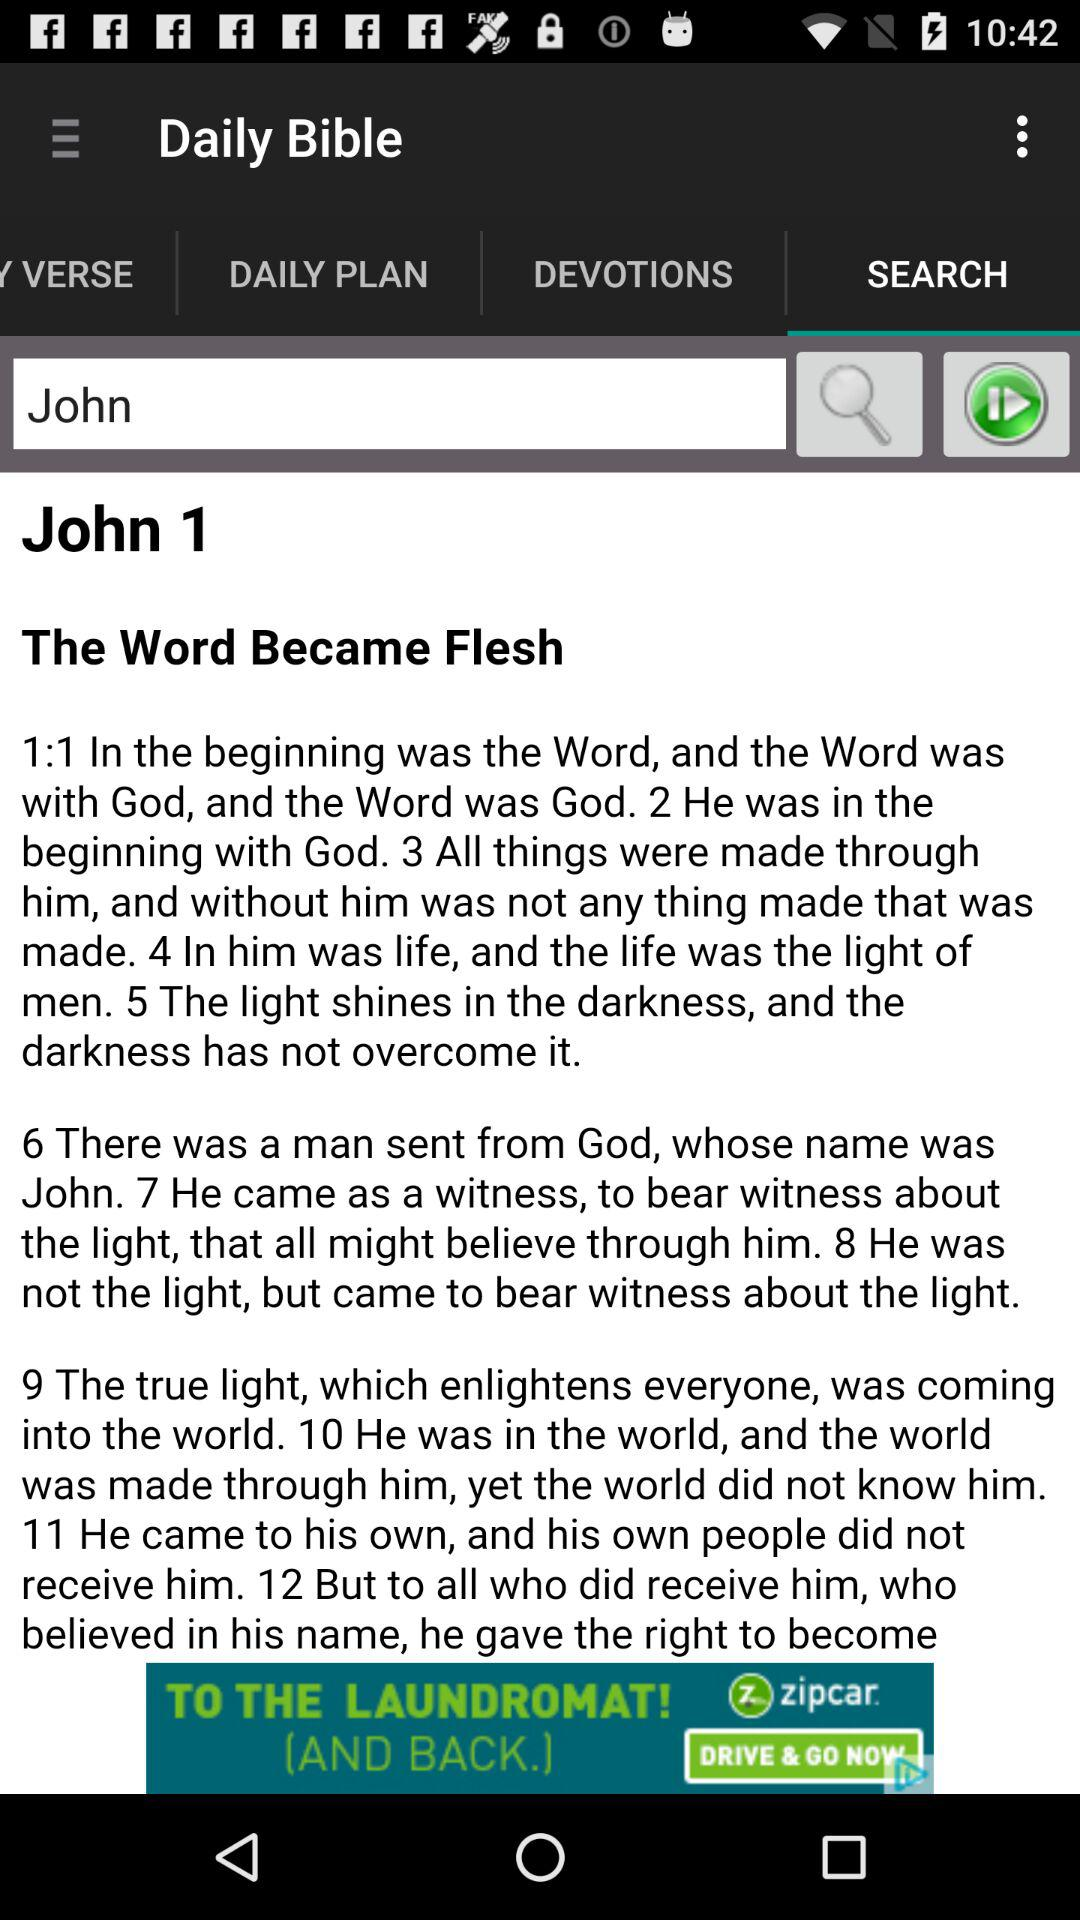Who enlightens everyone? The true light enlightens everyone. 